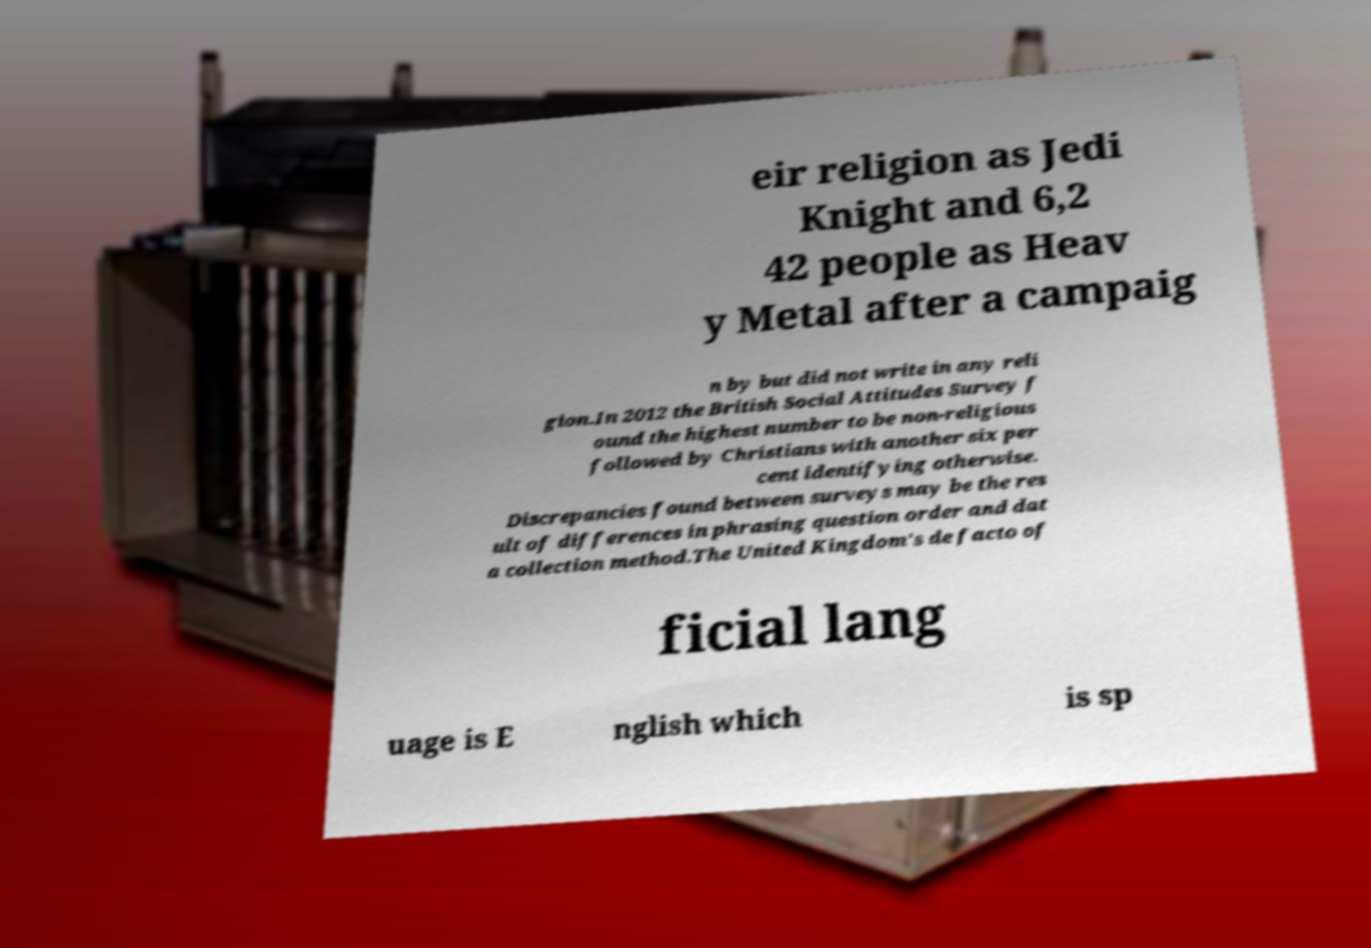What messages or text are displayed in this image? I need them in a readable, typed format. eir religion as Jedi Knight and 6,2 42 people as Heav y Metal after a campaig n by but did not write in any reli gion.In 2012 the British Social Attitudes Survey f ound the highest number to be non-religious followed by Christians with another six per cent identifying otherwise. Discrepancies found between surveys may be the res ult of differences in phrasing question order and dat a collection method.The United Kingdom's de facto of ficial lang uage is E nglish which is sp 